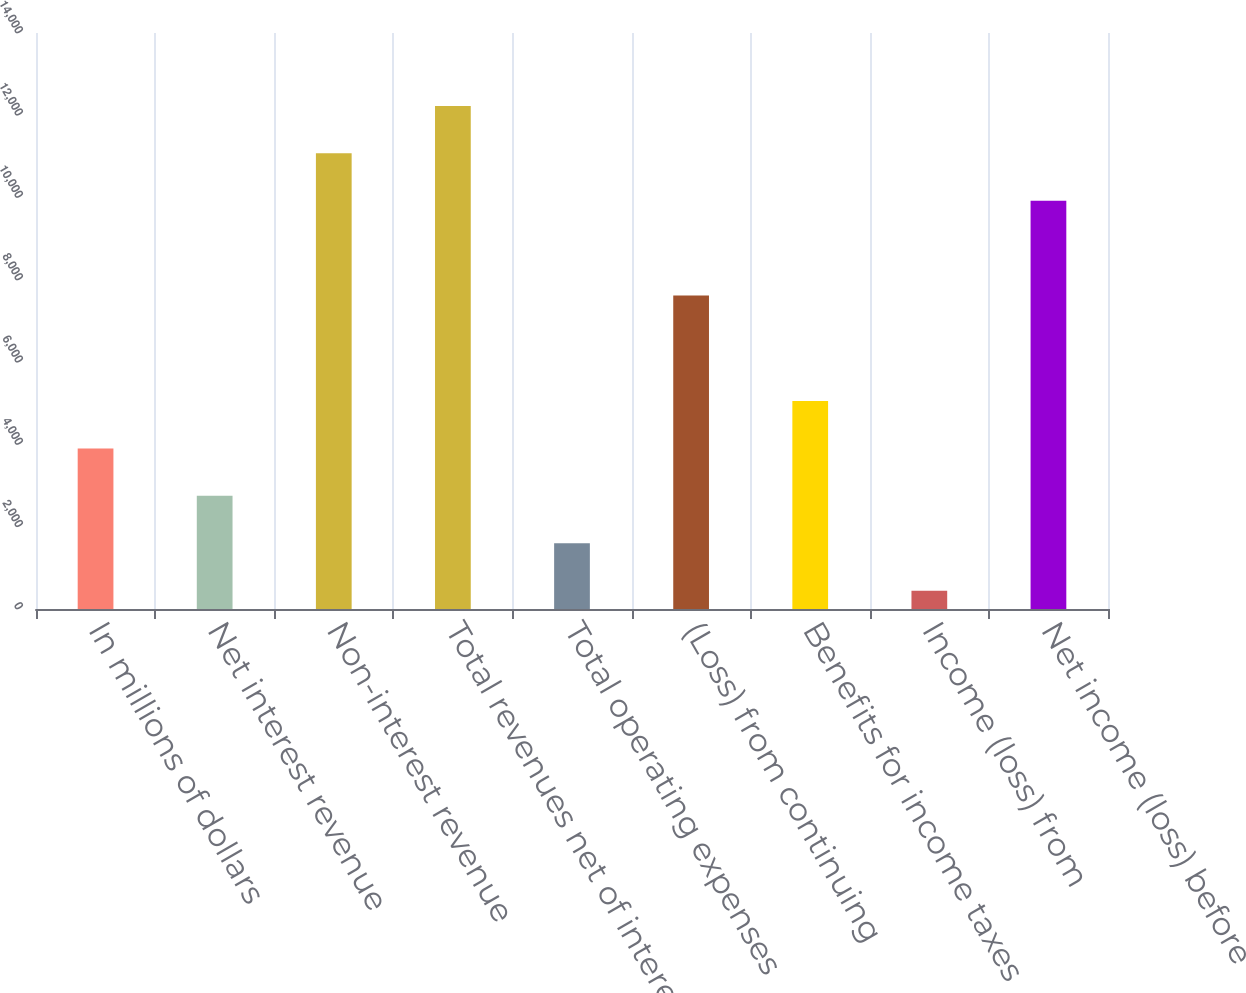Convert chart to OTSL. <chart><loc_0><loc_0><loc_500><loc_500><bar_chart><fcel>In millions of dollars<fcel>Net interest revenue<fcel>Non-interest revenue<fcel>Total revenues net of interest<fcel>Total operating expenses<fcel>(Loss) from continuing<fcel>Benefits for income taxes<fcel>Income (loss) from<fcel>Net income (loss) before<nl><fcel>3903.4<fcel>2750.6<fcel>11075.4<fcel>12228.2<fcel>1597.8<fcel>7617<fcel>5056.2<fcel>445<fcel>9922.6<nl></chart> 